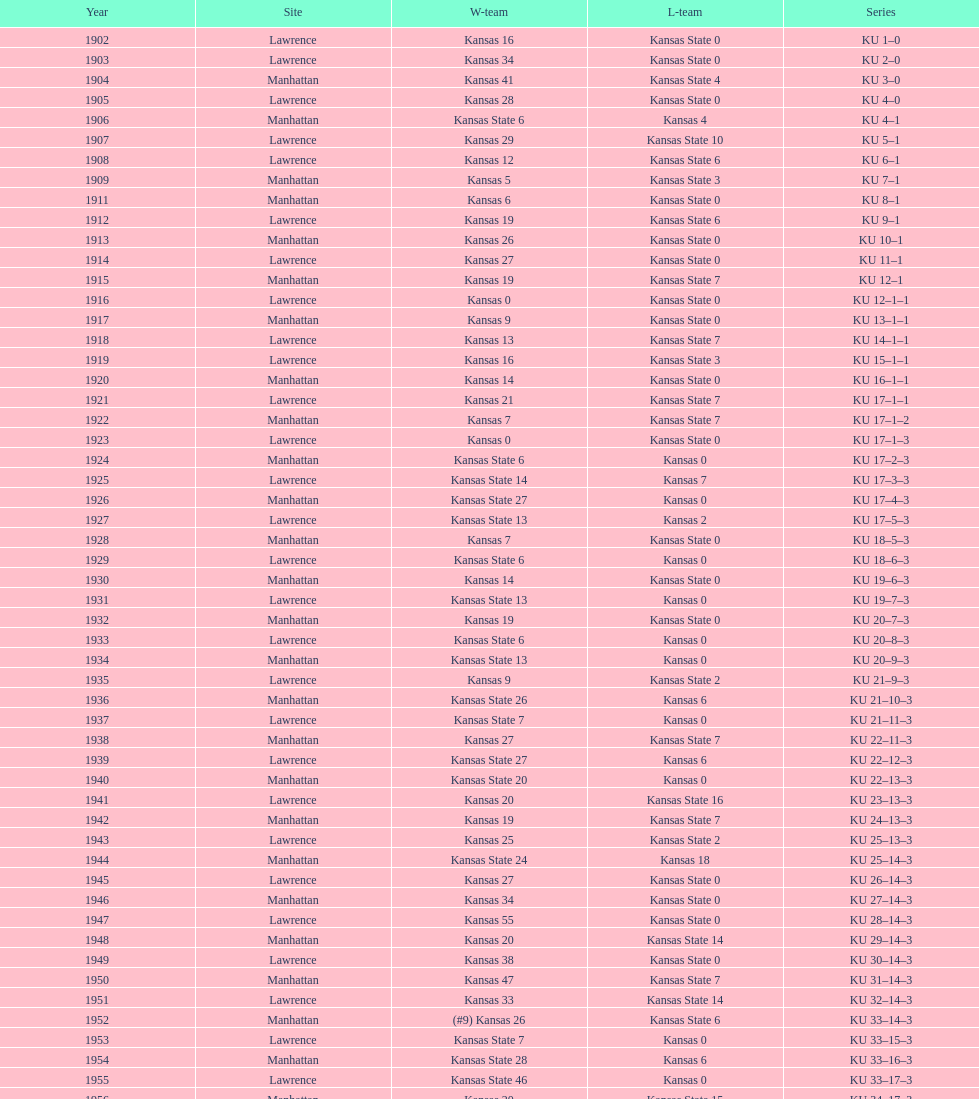Would you mind parsing the complete table? {'header': ['Year', 'Site', 'W-team', 'L-team', 'Series'], 'rows': [['1902', 'Lawrence', 'Kansas 16', 'Kansas State 0', 'KU 1–0'], ['1903', 'Lawrence', 'Kansas 34', 'Kansas State 0', 'KU 2–0'], ['1904', 'Manhattan', 'Kansas 41', 'Kansas State 4', 'KU 3–0'], ['1905', 'Lawrence', 'Kansas 28', 'Kansas State 0', 'KU 4–0'], ['1906', 'Manhattan', 'Kansas State 6', 'Kansas 4', 'KU 4–1'], ['1907', 'Lawrence', 'Kansas 29', 'Kansas State 10', 'KU 5–1'], ['1908', 'Lawrence', 'Kansas 12', 'Kansas State 6', 'KU 6–1'], ['1909', 'Manhattan', 'Kansas 5', 'Kansas State 3', 'KU 7–1'], ['1911', 'Manhattan', 'Kansas 6', 'Kansas State 0', 'KU 8–1'], ['1912', 'Lawrence', 'Kansas 19', 'Kansas State 6', 'KU 9–1'], ['1913', 'Manhattan', 'Kansas 26', 'Kansas State 0', 'KU 10–1'], ['1914', 'Lawrence', 'Kansas 27', 'Kansas State 0', 'KU 11–1'], ['1915', 'Manhattan', 'Kansas 19', 'Kansas State 7', 'KU 12–1'], ['1916', 'Lawrence', 'Kansas 0', 'Kansas State 0', 'KU 12–1–1'], ['1917', 'Manhattan', 'Kansas 9', 'Kansas State 0', 'KU 13–1–1'], ['1918', 'Lawrence', 'Kansas 13', 'Kansas State 7', 'KU 14–1–1'], ['1919', 'Lawrence', 'Kansas 16', 'Kansas State 3', 'KU 15–1–1'], ['1920', 'Manhattan', 'Kansas 14', 'Kansas State 0', 'KU 16–1–1'], ['1921', 'Lawrence', 'Kansas 21', 'Kansas State 7', 'KU 17–1–1'], ['1922', 'Manhattan', 'Kansas 7', 'Kansas State 7', 'KU 17–1–2'], ['1923', 'Lawrence', 'Kansas 0', 'Kansas State 0', 'KU 17–1–3'], ['1924', 'Manhattan', 'Kansas State 6', 'Kansas 0', 'KU 17–2–3'], ['1925', 'Lawrence', 'Kansas State 14', 'Kansas 7', 'KU 17–3–3'], ['1926', 'Manhattan', 'Kansas State 27', 'Kansas 0', 'KU 17–4–3'], ['1927', 'Lawrence', 'Kansas State 13', 'Kansas 2', 'KU 17–5–3'], ['1928', 'Manhattan', 'Kansas 7', 'Kansas State 0', 'KU 18–5–3'], ['1929', 'Lawrence', 'Kansas State 6', 'Kansas 0', 'KU 18–6–3'], ['1930', 'Manhattan', 'Kansas 14', 'Kansas State 0', 'KU 19–6–3'], ['1931', 'Lawrence', 'Kansas State 13', 'Kansas 0', 'KU 19–7–3'], ['1932', 'Manhattan', 'Kansas 19', 'Kansas State 0', 'KU 20–7–3'], ['1933', 'Lawrence', 'Kansas State 6', 'Kansas 0', 'KU 20–8–3'], ['1934', 'Manhattan', 'Kansas State 13', 'Kansas 0', 'KU 20–9–3'], ['1935', 'Lawrence', 'Kansas 9', 'Kansas State 2', 'KU 21–9–3'], ['1936', 'Manhattan', 'Kansas State 26', 'Kansas 6', 'KU 21–10–3'], ['1937', 'Lawrence', 'Kansas State 7', 'Kansas 0', 'KU 21–11–3'], ['1938', 'Manhattan', 'Kansas 27', 'Kansas State 7', 'KU 22–11–3'], ['1939', 'Lawrence', 'Kansas State 27', 'Kansas 6', 'KU 22–12–3'], ['1940', 'Manhattan', 'Kansas State 20', 'Kansas 0', 'KU 22–13–3'], ['1941', 'Lawrence', 'Kansas 20', 'Kansas State 16', 'KU 23–13–3'], ['1942', 'Manhattan', 'Kansas 19', 'Kansas State 7', 'KU 24–13–3'], ['1943', 'Lawrence', 'Kansas 25', 'Kansas State 2', 'KU 25–13–3'], ['1944', 'Manhattan', 'Kansas State 24', 'Kansas 18', 'KU 25–14–3'], ['1945', 'Lawrence', 'Kansas 27', 'Kansas State 0', 'KU 26–14–3'], ['1946', 'Manhattan', 'Kansas 34', 'Kansas State 0', 'KU 27–14–3'], ['1947', 'Lawrence', 'Kansas 55', 'Kansas State 0', 'KU 28–14–3'], ['1948', 'Manhattan', 'Kansas 20', 'Kansas State 14', 'KU 29–14–3'], ['1949', 'Lawrence', 'Kansas 38', 'Kansas State 0', 'KU 30–14–3'], ['1950', 'Manhattan', 'Kansas 47', 'Kansas State 7', 'KU 31–14–3'], ['1951', 'Lawrence', 'Kansas 33', 'Kansas State 14', 'KU 32–14–3'], ['1952', 'Manhattan', '(#9) Kansas 26', 'Kansas State 6', 'KU 33–14–3'], ['1953', 'Lawrence', 'Kansas State 7', 'Kansas 0', 'KU 33–15–3'], ['1954', 'Manhattan', 'Kansas State 28', 'Kansas 6', 'KU 33–16–3'], ['1955', 'Lawrence', 'Kansas State 46', 'Kansas 0', 'KU 33–17–3'], ['1956', 'Manhattan', 'Kansas 20', 'Kansas State 15', 'KU 34–17–3'], ['1957', 'Lawrence', 'Kansas 13', 'Kansas State 7', 'KU 35–17–3'], ['1958', 'Manhattan', 'Kansas 21', 'Kansas State 12', 'KU 36–17–3'], ['1959', 'Lawrence', 'Kansas 33', 'Kansas State 14', 'KU 37–17–3'], ['1960', 'Manhattan', 'Kansas 41', 'Kansas State 0', 'KU 38–17–3'], ['1961', 'Lawrence', 'Kansas 34', 'Kansas State 0', 'KU 39–17–3'], ['1962', 'Manhattan', 'Kansas 38', 'Kansas State 0', 'KU 40–17–3'], ['1963', 'Lawrence', 'Kansas 34', 'Kansas State 0', 'KU 41–17–3'], ['1964', 'Manhattan', 'Kansas 7', 'Kansas State 0', 'KU 42–17–3'], ['1965', 'Lawrence', 'Kansas 34', 'Kansas State 0', 'KU 43–17–3'], ['1966', 'Manhattan', 'Kansas 3', 'Kansas State 3', 'KU 43–17–4'], ['1967', 'Lawrence', 'Kansas 17', 'Kansas State 16', 'KU 44–17–4'], ['1968', 'Manhattan', '(#7) Kansas 38', 'Kansas State 29', 'KU 45–17–4']]} When was the first game that kansas state won by double digits? 1926. 